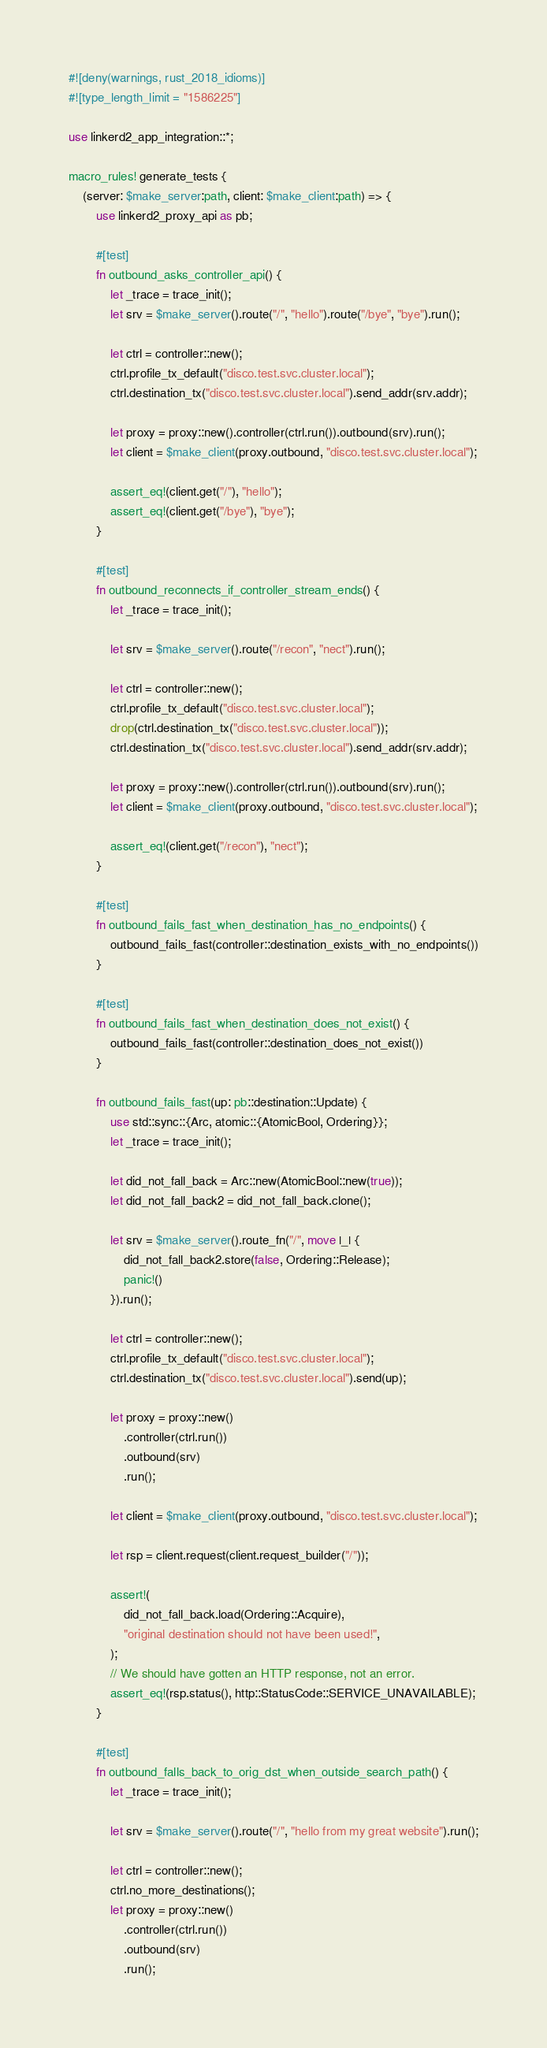Convert code to text. <code><loc_0><loc_0><loc_500><loc_500><_Rust_>#![deny(warnings, rust_2018_idioms)]
#![type_length_limit = "1586225"]

use linkerd2_app_integration::*;

macro_rules! generate_tests {
    (server: $make_server:path, client: $make_client:path) => {
        use linkerd2_proxy_api as pb;

        #[test]
        fn outbound_asks_controller_api() {
            let _trace = trace_init();
            let srv = $make_server().route("/", "hello").route("/bye", "bye").run();

            let ctrl = controller::new();
            ctrl.profile_tx_default("disco.test.svc.cluster.local");
            ctrl.destination_tx("disco.test.svc.cluster.local").send_addr(srv.addr);

            let proxy = proxy::new().controller(ctrl.run()).outbound(srv).run();
            let client = $make_client(proxy.outbound, "disco.test.svc.cluster.local");

            assert_eq!(client.get("/"), "hello");
            assert_eq!(client.get("/bye"), "bye");
        }

        #[test]
        fn outbound_reconnects_if_controller_stream_ends() {
            let _trace = trace_init();

            let srv = $make_server().route("/recon", "nect").run();

            let ctrl = controller::new();
            ctrl.profile_tx_default("disco.test.svc.cluster.local");
            drop(ctrl.destination_tx("disco.test.svc.cluster.local"));
            ctrl.destination_tx("disco.test.svc.cluster.local").send_addr(srv.addr);

            let proxy = proxy::new().controller(ctrl.run()).outbound(srv).run();
            let client = $make_client(proxy.outbound, "disco.test.svc.cluster.local");

            assert_eq!(client.get("/recon"), "nect");
        }

        #[test]
        fn outbound_fails_fast_when_destination_has_no_endpoints() {
            outbound_fails_fast(controller::destination_exists_with_no_endpoints())
        }

        #[test]
        fn outbound_fails_fast_when_destination_does_not_exist() {
            outbound_fails_fast(controller::destination_does_not_exist())
        }

        fn outbound_fails_fast(up: pb::destination::Update) {
            use std::sync::{Arc, atomic::{AtomicBool, Ordering}};
            let _trace = trace_init();

            let did_not_fall_back = Arc::new(AtomicBool::new(true));
            let did_not_fall_back2 = did_not_fall_back.clone();

            let srv = $make_server().route_fn("/", move |_| {
                did_not_fall_back2.store(false, Ordering::Release);
                panic!()
            }).run();

            let ctrl = controller::new();
            ctrl.profile_tx_default("disco.test.svc.cluster.local");
            ctrl.destination_tx("disco.test.svc.cluster.local").send(up);

            let proxy = proxy::new()
                .controller(ctrl.run())
                .outbound(srv)
                .run();

            let client = $make_client(proxy.outbound, "disco.test.svc.cluster.local");

            let rsp = client.request(client.request_builder("/"));

            assert!(
                did_not_fall_back.load(Ordering::Acquire),
                "original destination should not have been used!",
            );
            // We should have gotten an HTTP response, not an error.
            assert_eq!(rsp.status(), http::StatusCode::SERVICE_UNAVAILABLE);
        }

        #[test]
        fn outbound_falls_back_to_orig_dst_when_outside_search_path() {
            let _trace = trace_init();

            let srv = $make_server().route("/", "hello from my great website").run();

            let ctrl = controller::new();
            ctrl.no_more_destinations();
            let proxy = proxy::new()
                .controller(ctrl.run())
                .outbound(srv)
                .run();
</code> 